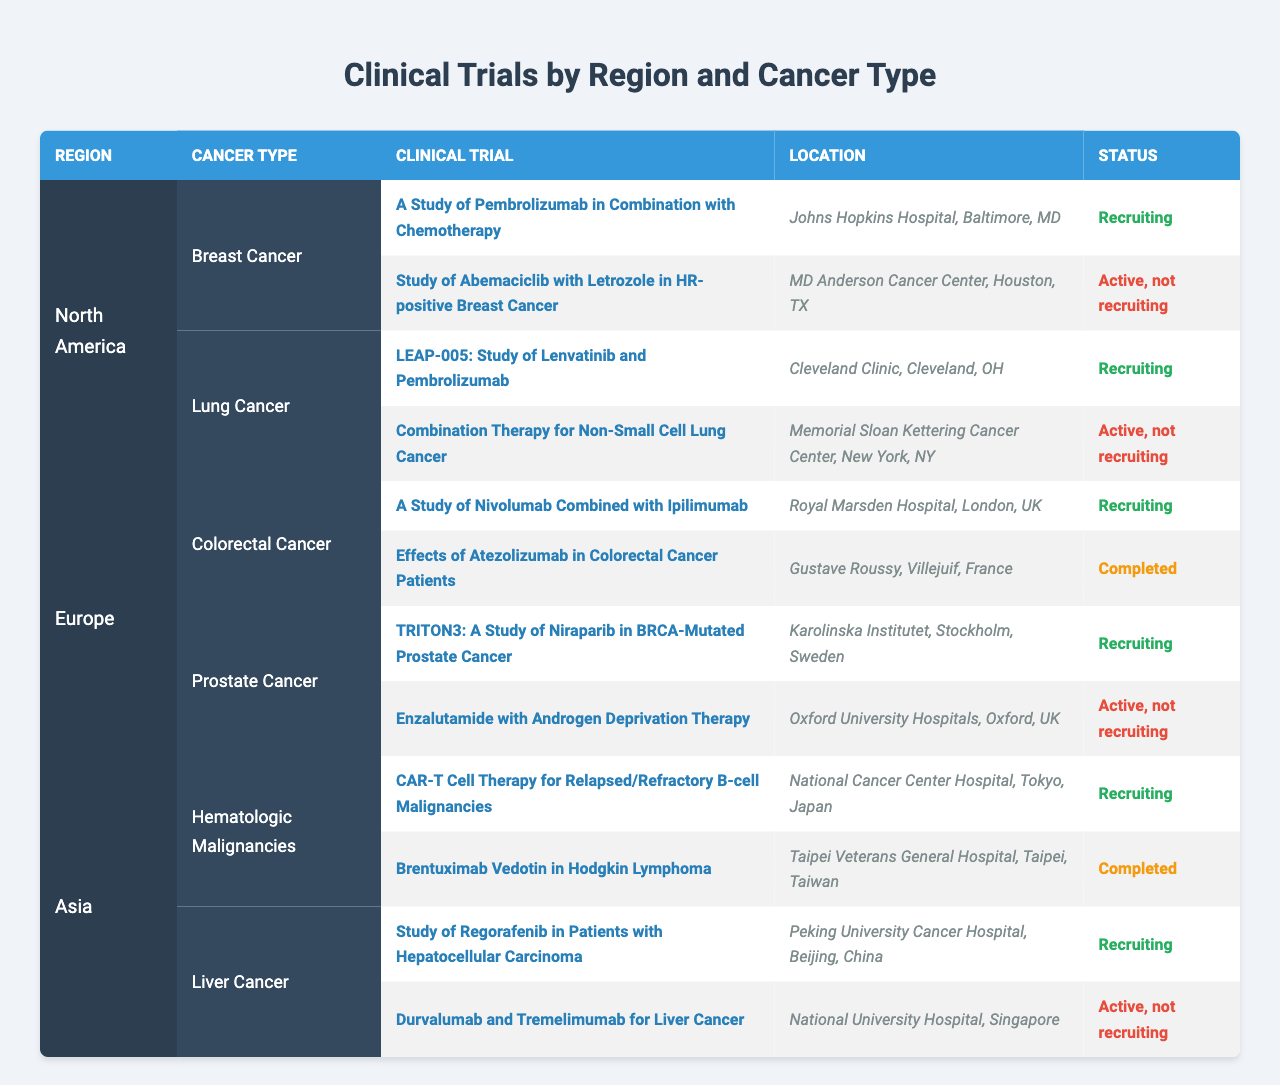What trials are currently recruiting for breast cancer in North America? There are two trials listed for breast cancer in North America. The first trial is "A Study of Pembrolizumab in Combination with Chemotherapy" at Johns Hopkins Hospital, Baltimore, MD, which is currently recruiting. The second trial is "Study of Abemaciclib with Letrozole in HR-positive Breast Cancer" at MD Anderson Cancer Center, Houston, TX; however, this trial is active but not recruiting. Therefore, only the first trial is currently recruiting.
Answer: A Study of Pembrolizumab in Combination with Chemotherapy How many total clinical trials are listed for prostate cancer in Europe? There are two trials listed for prostate cancer in Europe. They are "TRITON3: A Study of Niraparib in BRCA-Mutated Prostate Cancer" and "Enzalutamide with Androgen Deprivation Therapy." Thus, the total number is two.
Answer: 2 Is there a clinical trial for hepatocellular carcinoma that is currently recruiting? Yes, there is a clinical trial titled "Study of Regorafenib in Patients with Hepatocellular Carcinoma" located at Peking University Cancer Hospital, Beijing, China, and it is currently recruiting.
Answer: Yes What is the status of the clinical trial "Effects of Atezolizumab in Colorectal Cancer Patients"? The status of this clinical trial, located at Gustave Roussy, Villejuif, France, is completed. Since it does not indicate that it is recruiting or active, the trial is marked as completed.
Answer: Completed How many recruiting trials are there for lung cancer compared to breast cancer in North America? In North America, there are two recruiting trials: one for lung cancer, "LEAP-005: Study of Lenvatinib and Pembrolizumab" and one for breast cancer, "A Study of Pembrolizumab in Combination with Chemotherapy." Thus, for lung cancer, there is one recruiting trial, and for breast cancer, there is also one. Comparing the two, they are both equal in number, with one recruiting trial each.
Answer: 1 each 